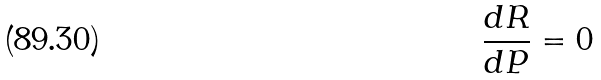<formula> <loc_0><loc_0><loc_500><loc_500>\frac { d R } { d P } = 0</formula> 